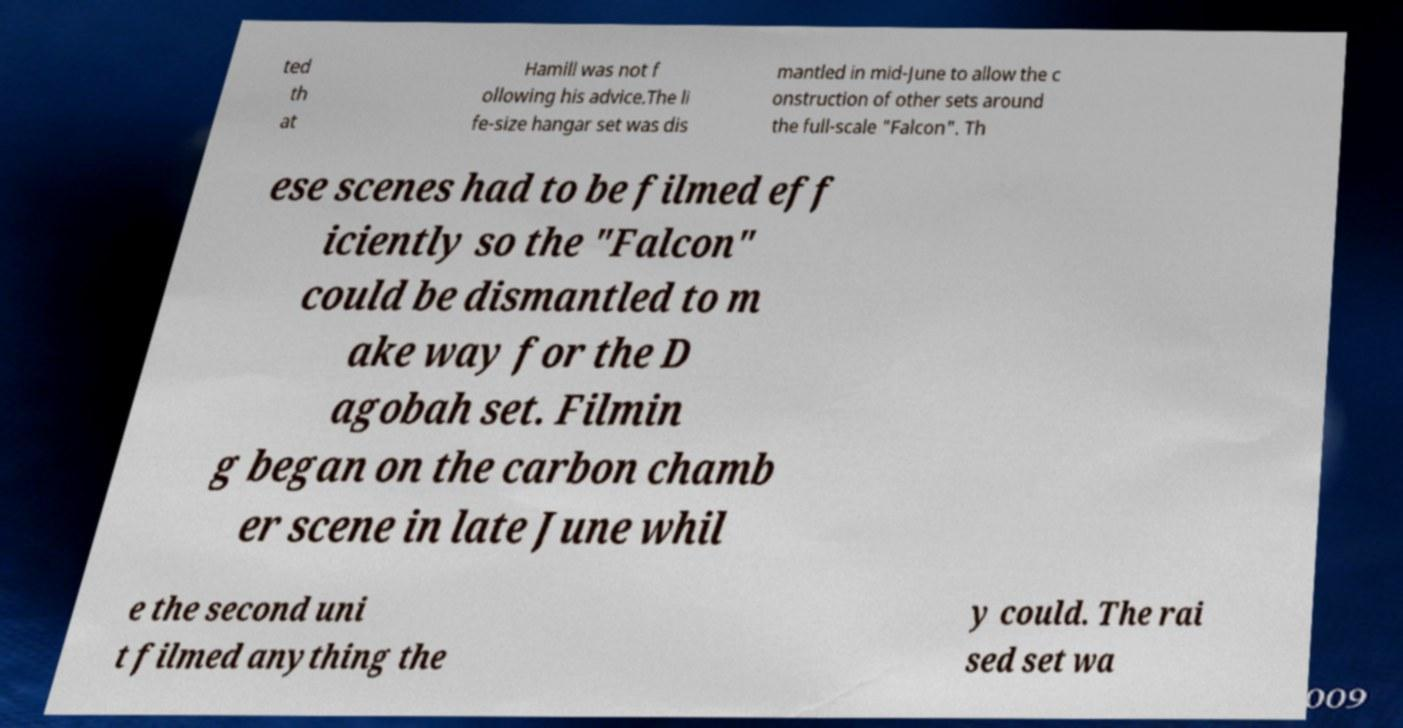Please read and relay the text visible in this image. What does it say? ted th at Hamill was not f ollowing his advice.The li fe-size hangar set was dis mantled in mid-June to allow the c onstruction of other sets around the full-scale "Falcon". Th ese scenes had to be filmed eff iciently so the "Falcon" could be dismantled to m ake way for the D agobah set. Filmin g began on the carbon chamb er scene in late June whil e the second uni t filmed anything the y could. The rai sed set wa 